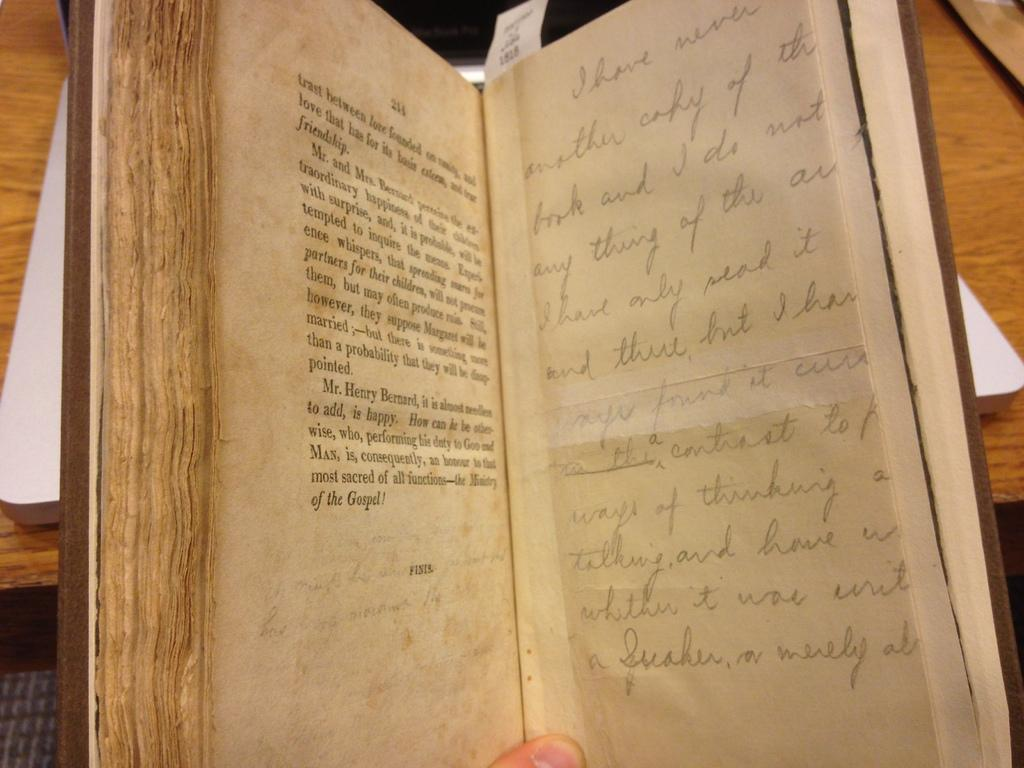<image>
Describe the image concisely. the word performing is on the page of the book 